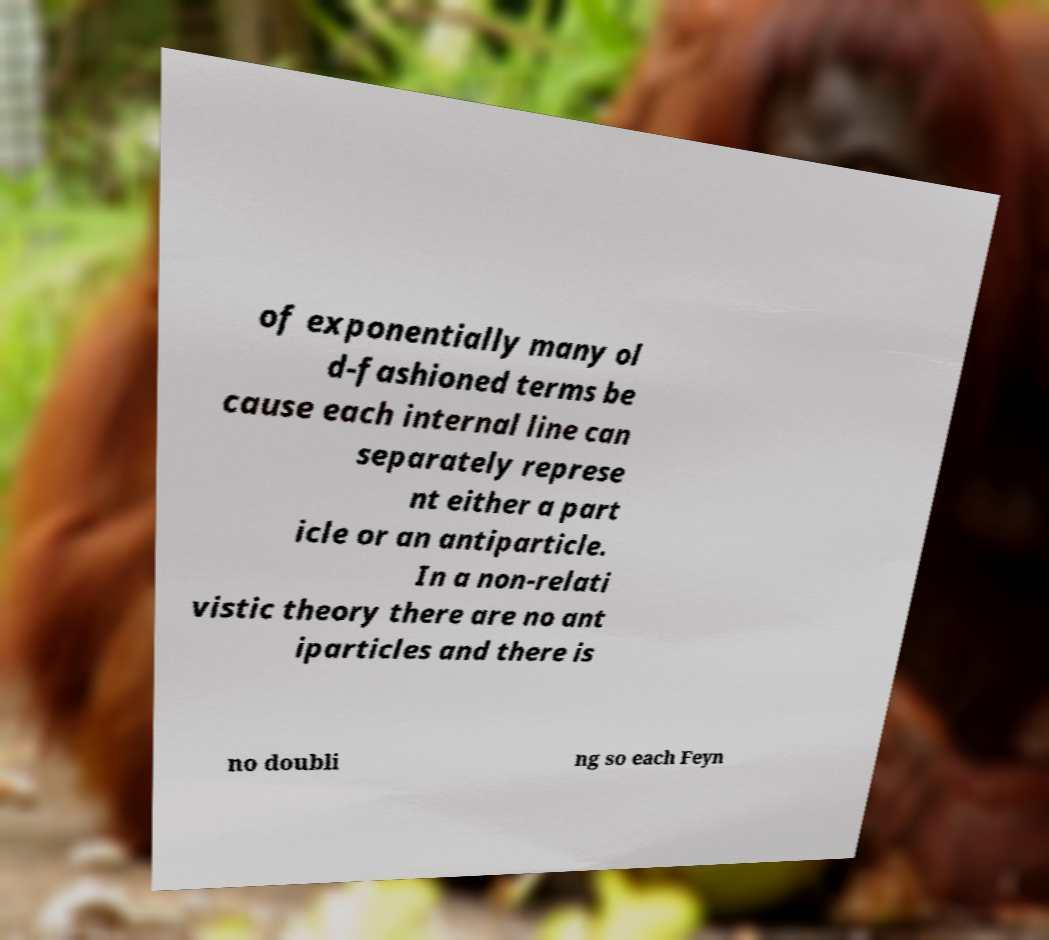There's text embedded in this image that I need extracted. Can you transcribe it verbatim? of exponentially many ol d-fashioned terms be cause each internal line can separately represe nt either a part icle or an antiparticle. In a non-relati vistic theory there are no ant iparticles and there is no doubli ng so each Feyn 